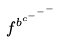Convert formula to latex. <formula><loc_0><loc_0><loc_500><loc_500>f ^ { b ^ { c ^ { - ^ { - ^ { - } } } } }</formula> 